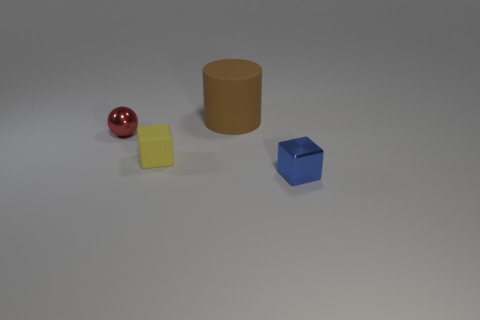What number of small spheres have the same color as the big object?
Keep it short and to the point. 0. What shape is the other object that is made of the same material as the brown thing?
Your answer should be very brief. Cube. What size is the rubber object behind the small yellow rubber thing?
Your answer should be very brief. Large. Are there an equal number of tiny matte blocks that are behind the tiny red object and small blue blocks that are in front of the large brown thing?
Your response must be concise. No. There is a small cube left of the small metallic thing on the right side of the metallic thing that is left of the tiny blue cube; what is its color?
Your answer should be compact. Yellow. What number of cubes are to the left of the tiny blue thing and on the right side of the small yellow matte block?
Give a very brief answer. 0. Does the block in front of the small yellow cube have the same color as the cube left of the big cylinder?
Your response must be concise. No. Is there any other thing that is the same material as the small ball?
Ensure brevity in your answer.  Yes. There is another metal thing that is the same shape as the yellow thing; what is its size?
Offer a terse response. Small. Are there any rubber cylinders to the right of the brown rubber cylinder?
Offer a terse response. No. 